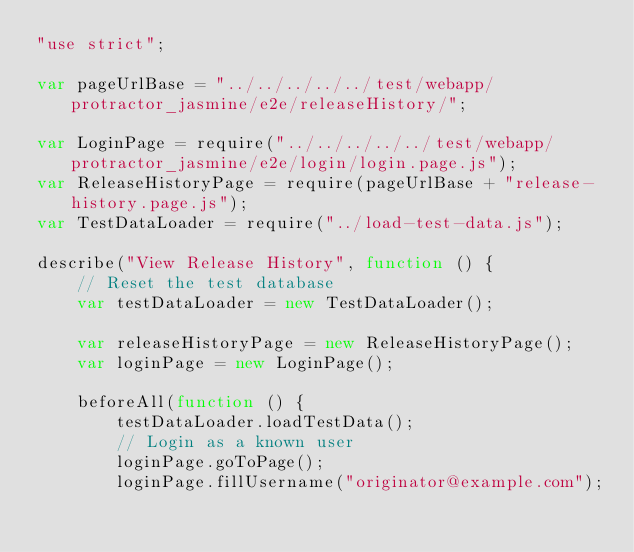Convert code to text. <code><loc_0><loc_0><loc_500><loc_500><_JavaScript_>"use strict";

var pageUrlBase = "../../../../../test/webapp/protractor_jasmine/e2e/releaseHistory/";

var LoginPage = require("../../../../../test/webapp/protractor_jasmine/e2e/login/login.page.js");
var ReleaseHistoryPage = require(pageUrlBase + "release-history.page.js");
var TestDataLoader = require("../load-test-data.js");

describe("View Release History", function () {
    // Reset the test database
    var testDataLoader = new TestDataLoader();

    var releaseHistoryPage = new ReleaseHistoryPage();
    var loginPage = new LoginPage();

    beforeAll(function () {
        testDataLoader.loadTestData();
        // Login as a known user
        loginPage.goToPage();
        loginPage.fillUsername("originator@example.com");</code> 